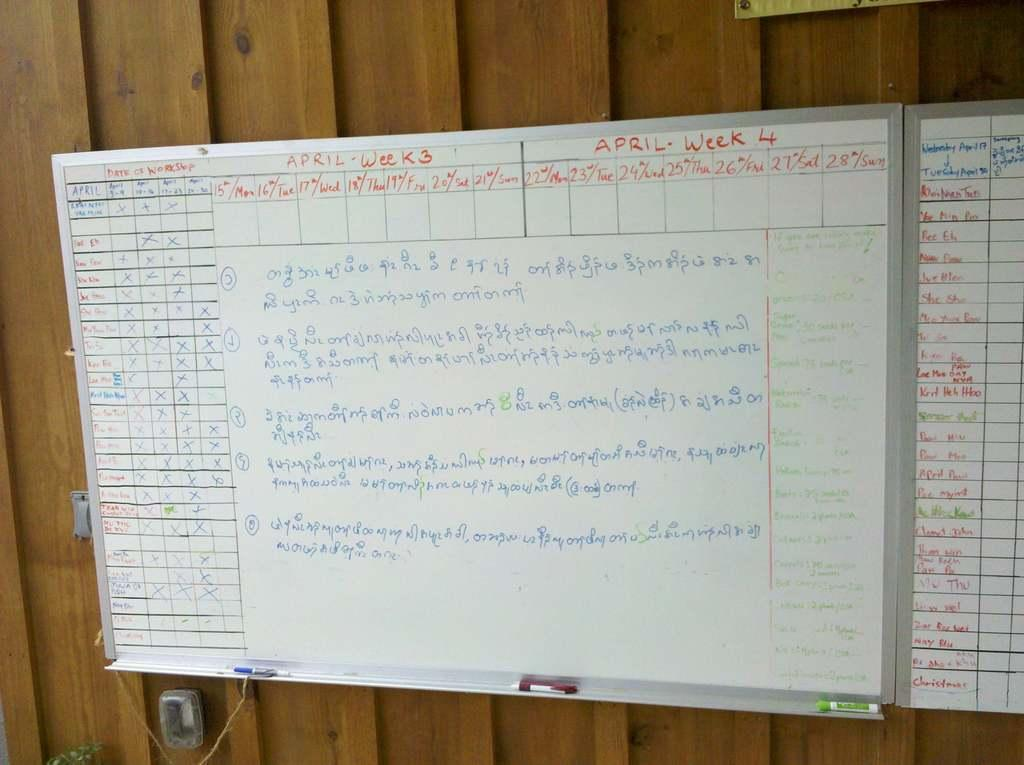Provide a one-sentence caption for the provided image. A whiteboard with writing in Arabic showing topics for week 3 and 4 of April. 